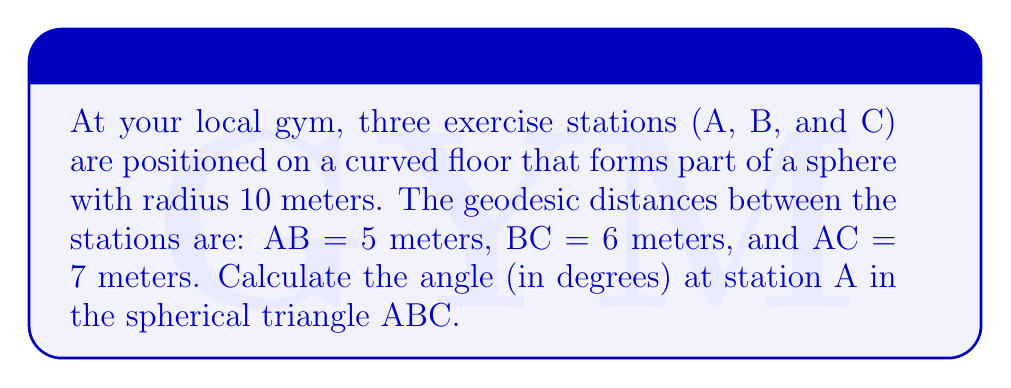Help me with this question. To solve this problem, we'll use the spherical law of cosines. Let's approach this step-by-step:

1) The spherical law of cosines states:
   $$\cos(c) = \cos(a)\cos(b) + \sin(a)\sin(b)\cos(C)$$
   where a, b, and c are the side lengths of the spherical triangle (measured in radians), and C is the angle opposite side c.

2) We need to convert the given distances to radians. The formula is:
   $$\text{angle in radians} = \frac{\text{arc length}}{\text{radius}}$$

3) Converting our side lengths:
   $$a = \frac{5}{10} = 0.5 \text{ radians}$$
   $$b = \frac{6}{10} = 0.6 \text{ radians}$$
   $$c = \frac{7}{10} = 0.7 \text{ radians}$$

4) We want to find angle A, which is opposite side a (BC). So we'll use:
   $$\cos(0.6) = \cos(0.5)\cos(0.7) + \sin(0.5)\sin(0.7)\cos(A)$$

5) Let's solve for $\cos(A)$:
   $$\cos(A) = \frac{\cos(0.6) - \cos(0.5)\cos(0.7)}{\sin(0.5)\sin(0.7)}$$

6) Calculating:
   $$\cos(A) = \frac{0.8253 - (0.8776 \times 0.7648)}{0.4794 \times 0.6442} \approx 0.2323$$

7) To get A, we take the inverse cosine and convert to degrees:
   $$A = \arccos(0.2323) \times \frac{180}{\pi} \approx 76.57°$$

[asy]
import geometry;

size(200);
pair A = (0,0), B = (100,0), C = (50,86.6);
draw(A--B--C--cycle);
label("A", A, SW);
label("B", B, SE);
label("C", C, N);
label("5m", (A+B)/2, S);
label("6m", (B+C)/2, NE);
label("7m", (A+C)/2, NW);
draw(arc(A,30,0,76.57), blue);
label("76.57°", A+(20,10), blue);
</asy]
Answer: 76.57° 